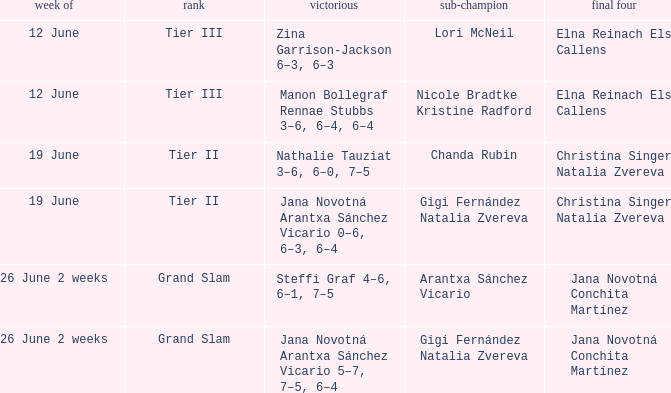When the runner-up is listed as Gigi Fernández Natalia Zvereva and the week is 26 June 2 weeks, who are the semi finalists? Jana Novotná Conchita Martínez. 